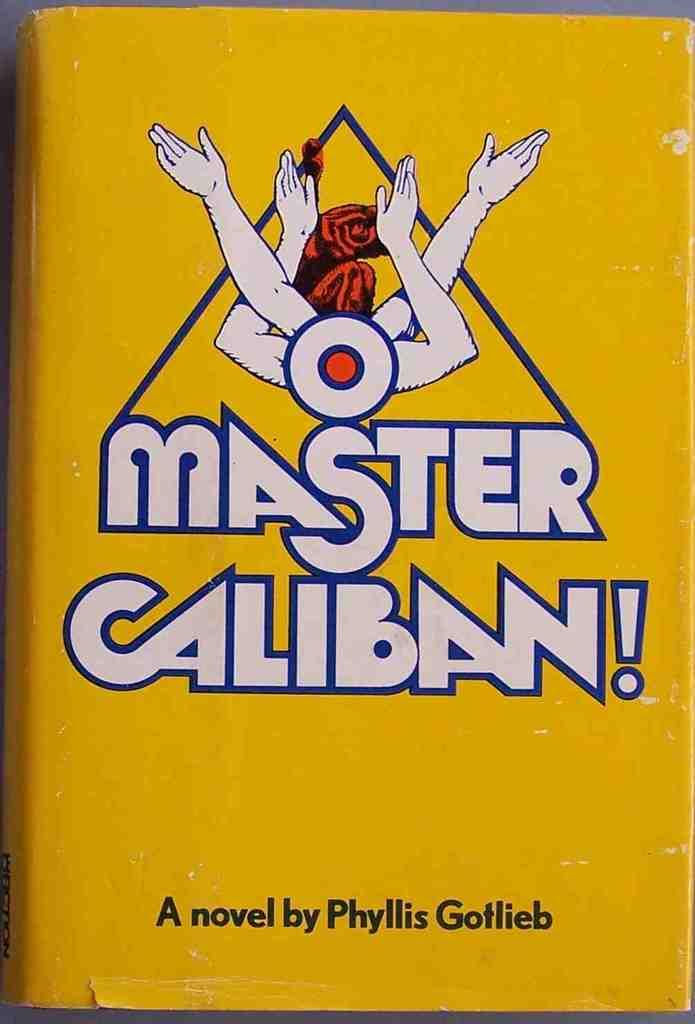<image>
Describe the image concisely. Phyllis Gotlieb wrote a novel called Master Caliban! 